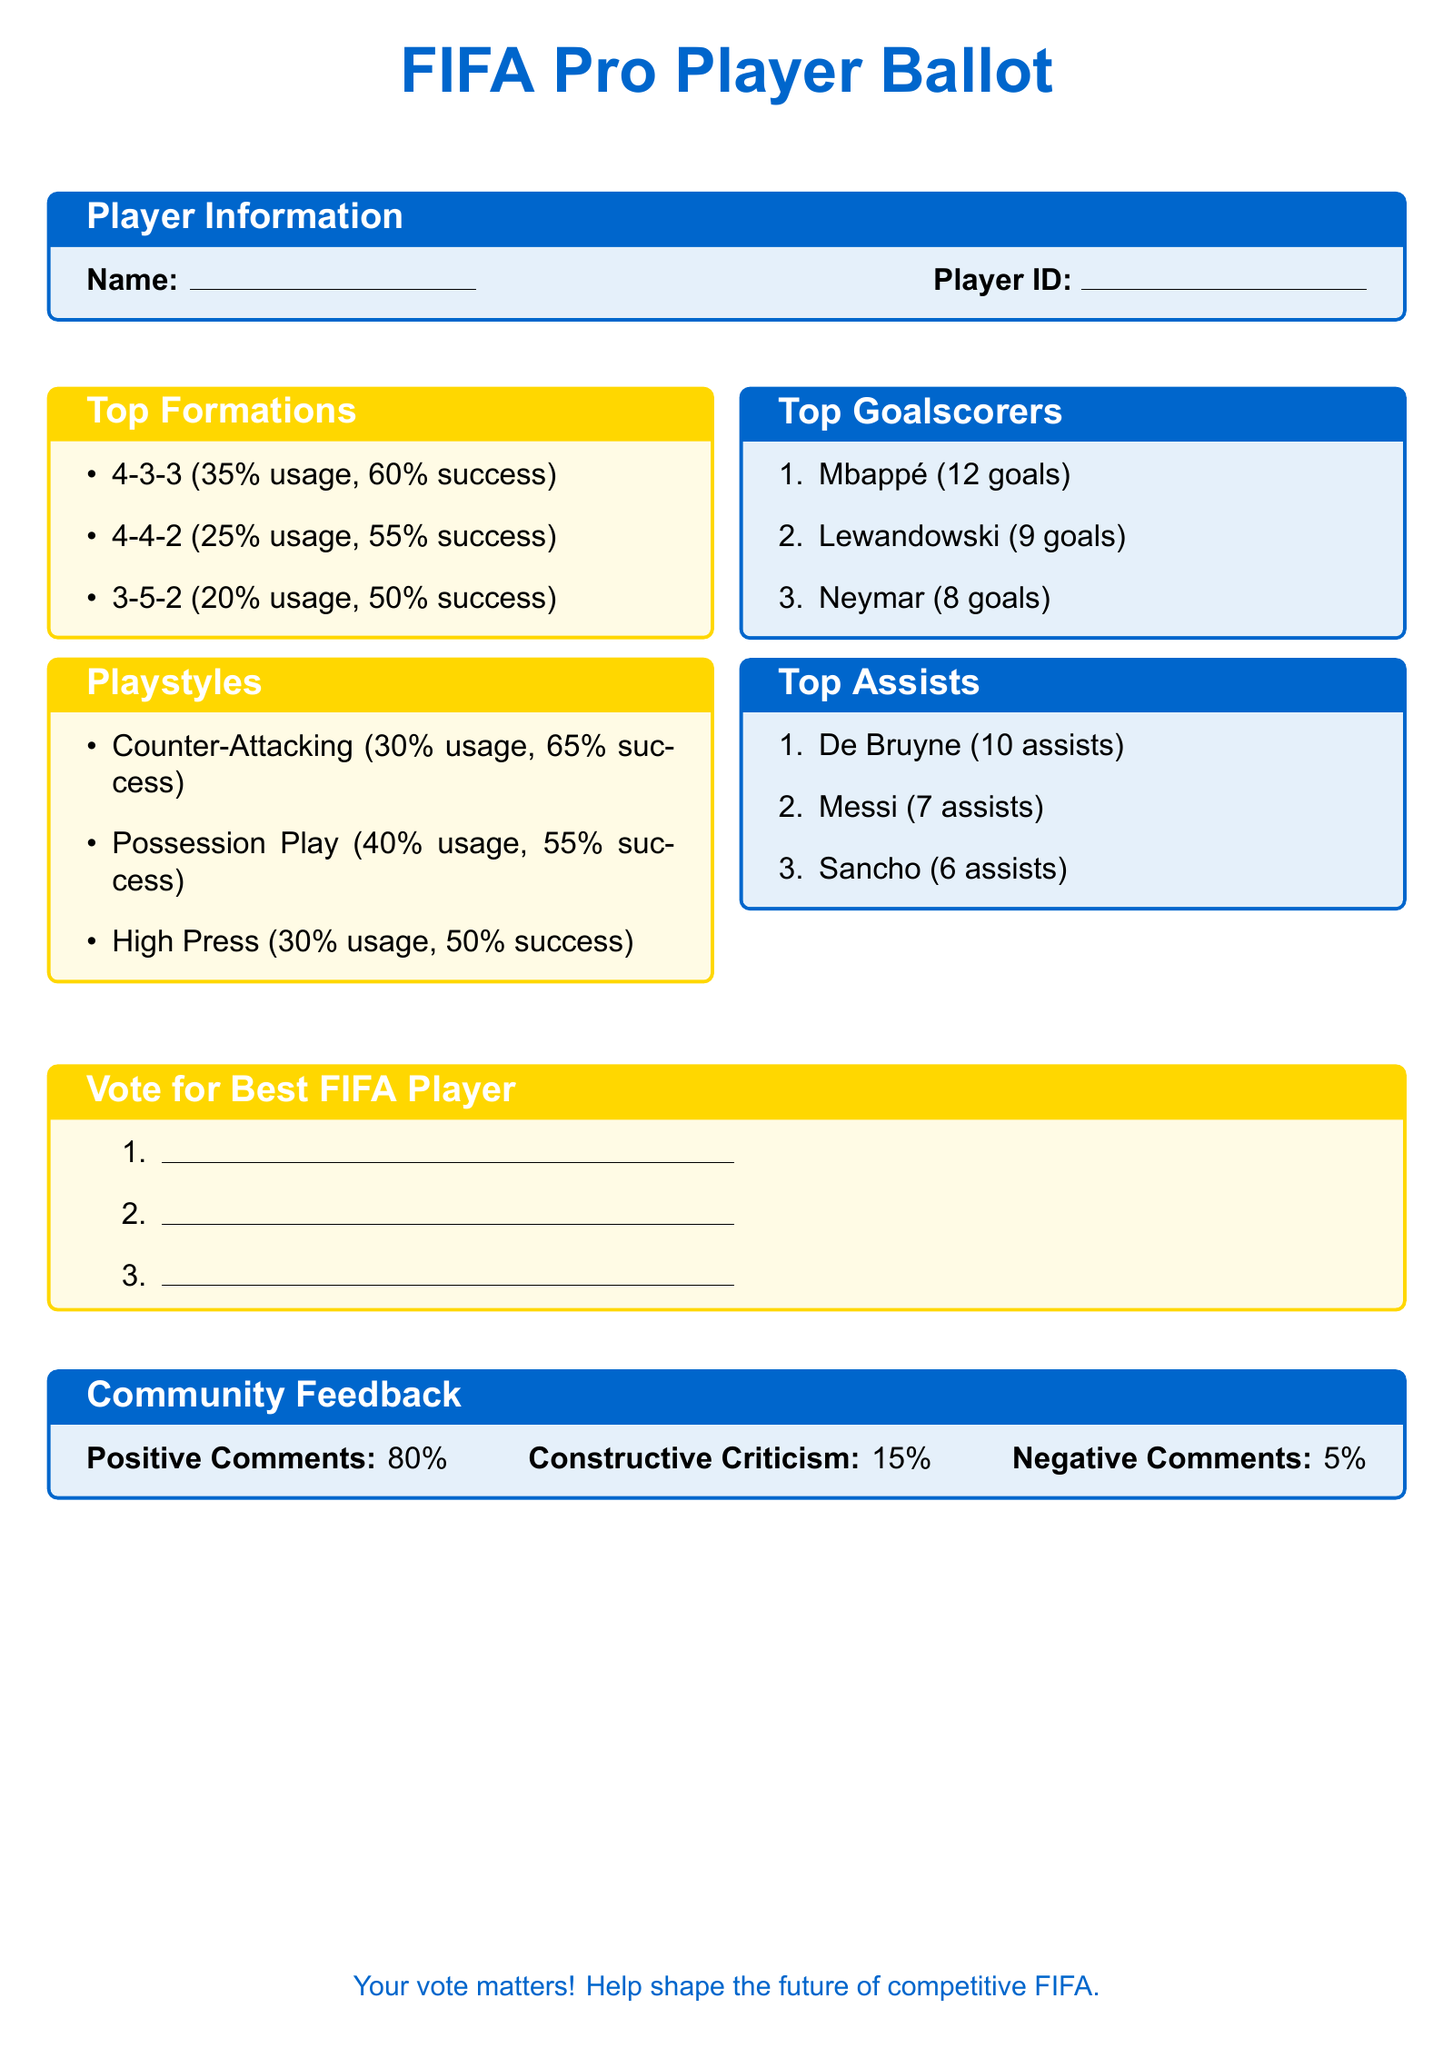What is the player information section about? The player information section collects the player's name and ID, which are used to identify them in the ballot.
Answer: Player's name and ID What is the most successful formation listed? The success rate is combined with the usage percentage to deduce that the 4-3-3 formation has the highest success rate at 60%.
Answer: 4-3-3 Which playstyle has the highest usage rate? The playstyle with the highest usage rate indicates players tend to favor possession-style games at 40%.
Answer: Possession Play How many goals did Mbappé score? Mbappé is listed as the top goalscorer, with a total of 12 goals.
Answer: 12 goals What percentage of community feedback was positive? The document states that 80% of community feedback consists of positive comments, which is the majority.
Answer: 80% Which player has the most assists? The document identifies De Bruyne as having the highest assists with a total of 10.
Answer: De Bruyne What is the purpose of the ballot? The ballot is designed to gather votes for the best FIFA player, reflecting community input in the competitive scene.
Answer: Vote for Best FIFA Player Which formation has the least usage? Among the formations listed, the 3-5-2 has the lowest usage at 20%.
Answer: 3-5-2 What is the percentage of negative comments from community feedback? The negative comments represent a small portion of the feedback at 5%, indicating minimal dissatisfaction.
Answer: 5% 